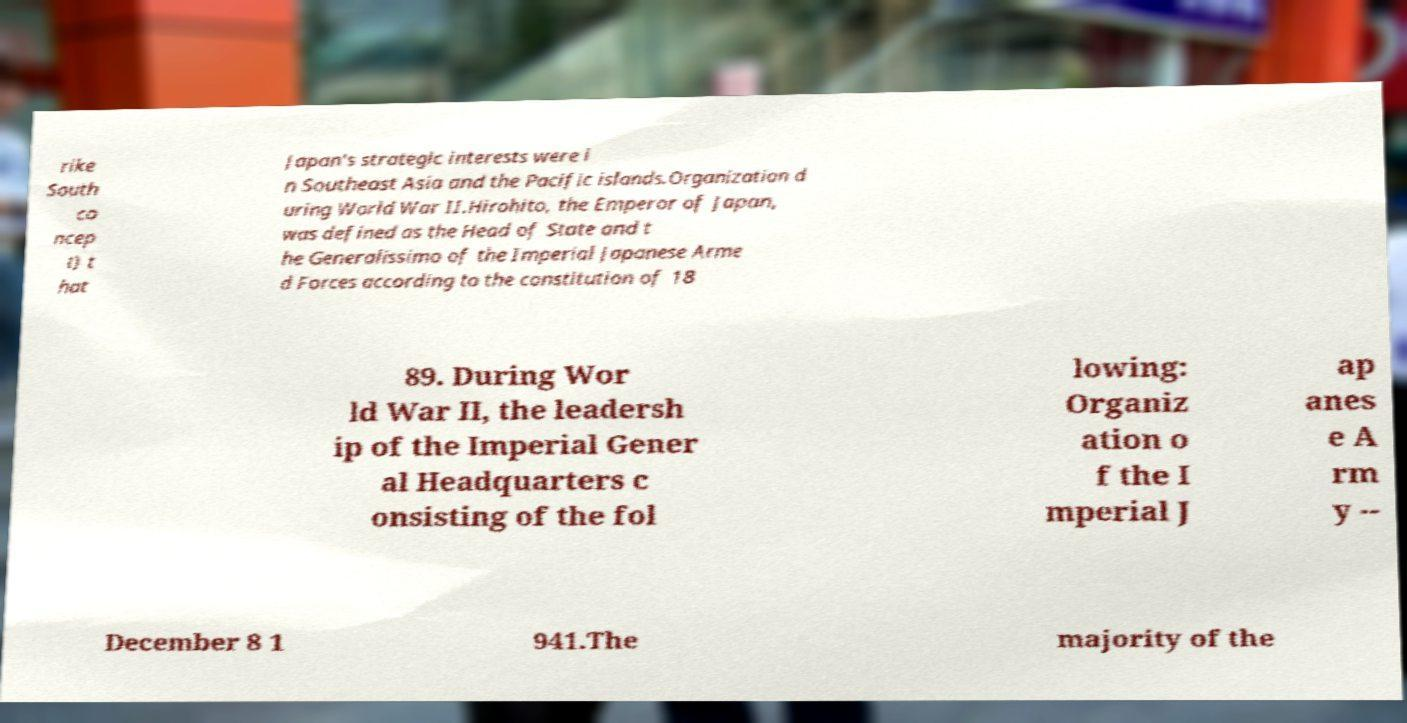I need the written content from this picture converted into text. Can you do that? rike South co ncep t) t hat Japan's strategic interests were i n Southeast Asia and the Pacific islands.Organization d uring World War II.Hirohito, the Emperor of Japan, was defined as the Head of State and t he Generalissimo of the Imperial Japanese Arme d Forces according to the constitution of 18 89. During Wor ld War II, the leadersh ip of the Imperial Gener al Headquarters c onsisting of the fol lowing: Organiz ation o f the I mperial J ap anes e A rm y -- December 8 1 941.The majority of the 